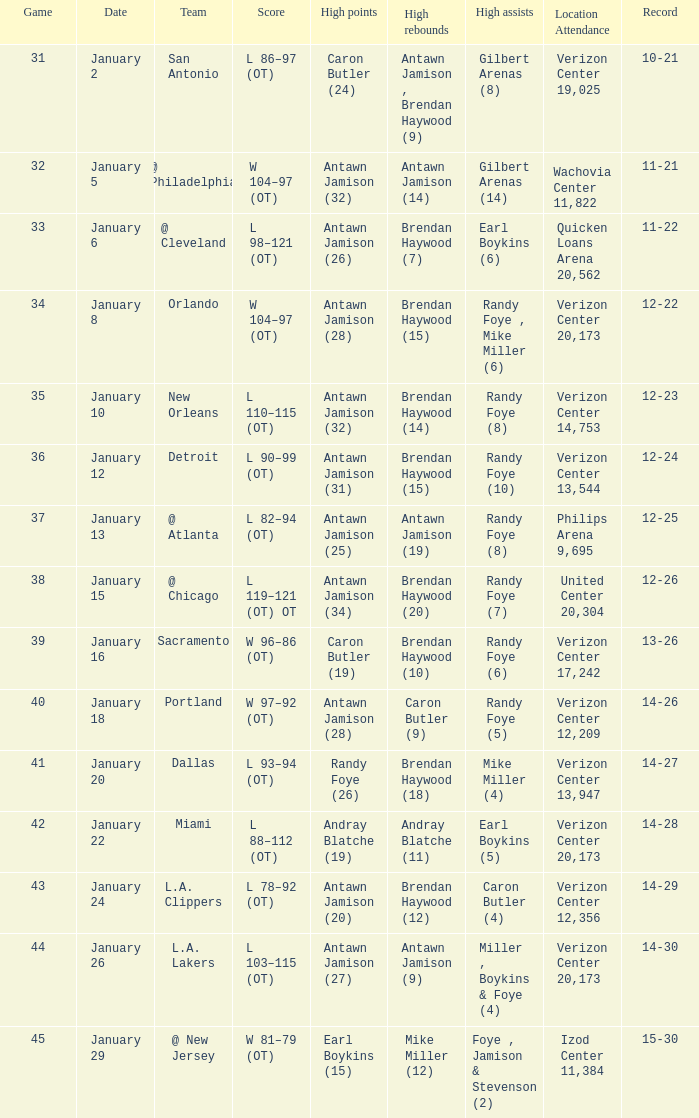How many people got high points in game 35? 1.0. 